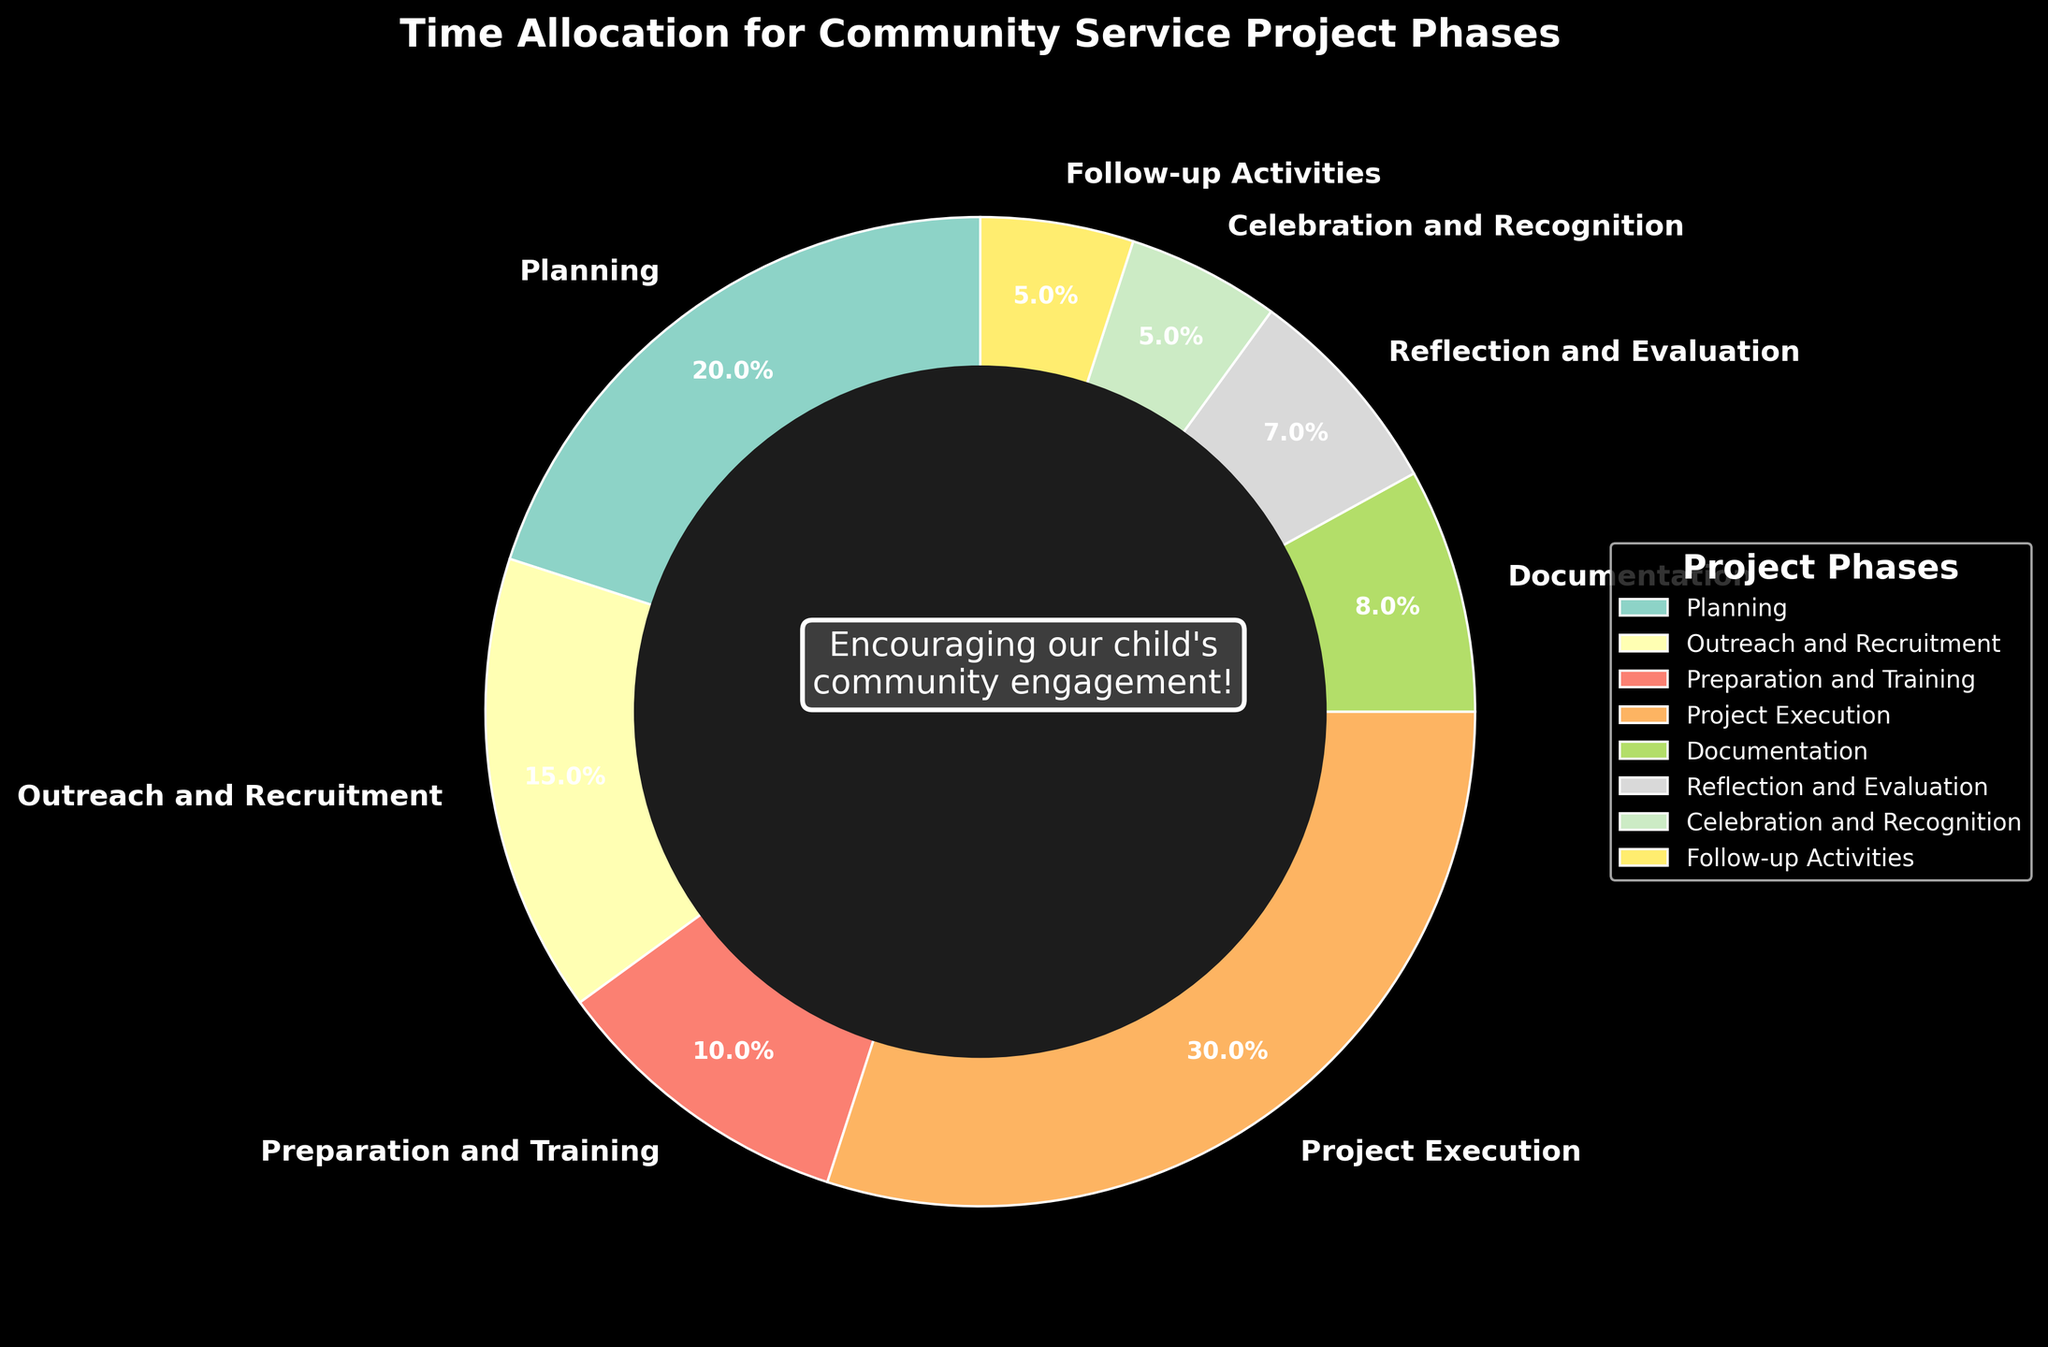What's the largest phase by time percentage? To find the largest phase, we look for the segment with the highest percentage. The "Project Execution" phase takes 30%, which is the biggest slice on the pie chart.
Answer: Project Execution Which two phases have equal time allocation? By observing the segments, we note that both "Celebration and Recognition" and "Follow-up Activities" have the same percentage of 5%.
Answer: Celebration and Recognition and Follow-up Activities What is the combined time percentage for Planning and Outreach and Recruitment? The Planning phase is 20%, and the Outreach and Recruitment phase is 15%. Summing them up, 20% + 15% = 35%.
Answer: 35% Is the Documentation phase allocation less than the Preparation and Training phase? The pie chart shows the Documentation phase is 8%, and the Preparation and Training phase is 10%. Since 8% is less than 10%, the answer is yes.
Answer: Yes What is the average time percentage allocated to Reflection and Evaluation, Celebration and Recognition, and Follow-up Activities? The Reflection and Evaluation phase is 7%, Celebration and Recognition is 5%, and Follow-up Activities is 5%. Summing them up, 7% + 5% + 5% = 17%. The average is 17% / 3 = 5.67%.
Answer: 5.67% Which phases combined take up exactly 50% of the project time? By summing the percentages, we see that the Planning (20%) and Project Execution (30%) phases together make up 20% + 30% = 50%.
Answer: Planning and Project Execution How much more time is spent on Project Execution compared to Documentation and Reflection and Evaluation combined? The Project Execution phase is 30%. Documentation is 8% and Reflection and Evaluation is 7%, so their combined percentage is 8% + 7% = 15%. The difference is 30% - 15% = 15%.
Answer: 15% What is the difference in percentage between the Planning phase and the Preparation and Training phase? The Planning phase is 20% and the Preparation and Training phase is 10%. The difference is 20% - 10% = 10%.
Answer: 10% Which phase has the smallest time allocation, and what is its percentage? The smallest segment on the pie chart is the "Follow-up Activities" and "Celebration and Recognition," both of which are 5%. Since they are equal, either one can be considered the smallest.
Answer: Follow-up Activities or Celebration and Recognition, 5% What percentage of the project time is not dedicated to Project Execution? The Project Execution phase takes 30%. The total percentage is 100%, so subtracting 30% gives 100% - 30% = 70%.
Answer: 70% 